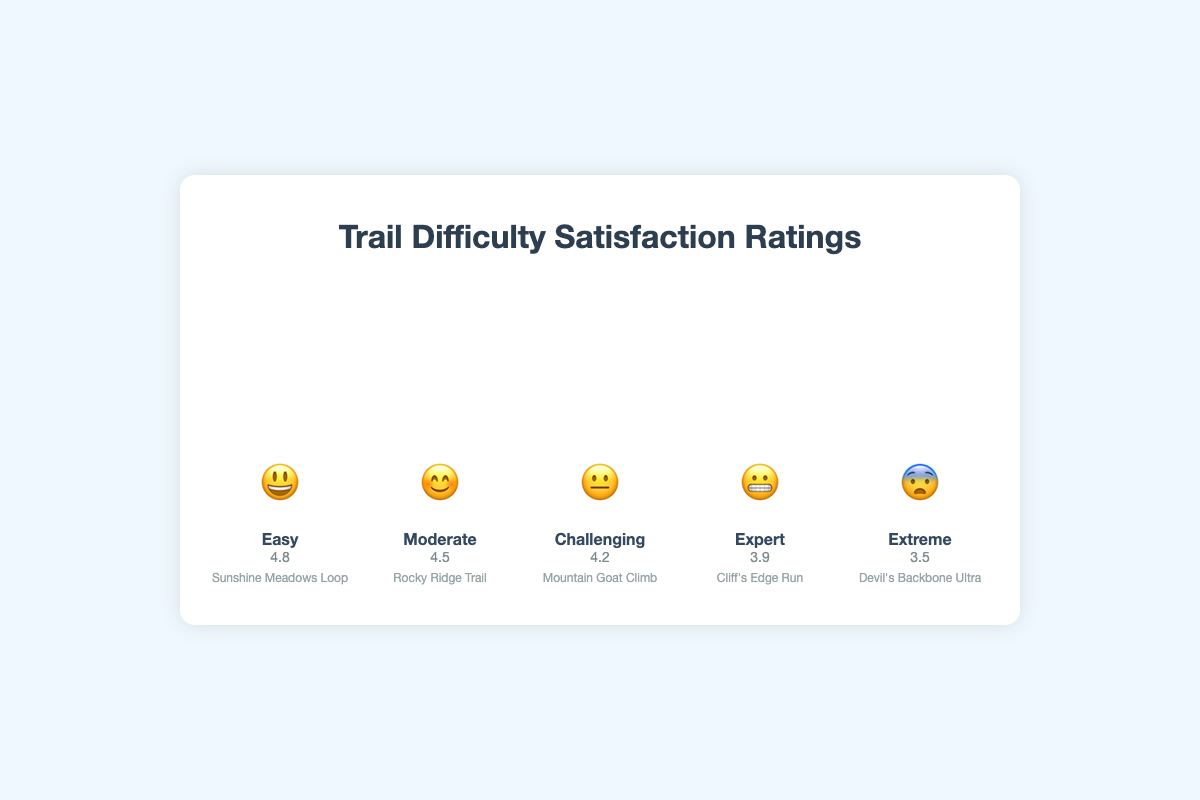what is the trail difficulty level with the highest satisfaction rating? Looking at the figure, the height of the bars represents the satisfaction ratings. The highest bar, corresponding to the satisfaction rating of 4.8, is associated with the "Easy" trail difficulty level.
Answer: Easy which emoji corresponds to the "Challenging" trail difficulty level? In the figure, each trail difficulty level is represented by an emoji. The "Challenging" trail difficulty level is denoted with the 😐 emoji.
Answer: 😐 what is the approximate satisfaction rating for the "Expert" trail difficulty level? The satisfaction rating is shown on the bar for each difficulty level. For the "Expert" level, the satisfaction rating is around 3.9.
Answer: 3.9 what is the satisfaction rating difference between the "Easy" and "Extreme" trail difficulty levels? The satisfaction rating for "Easy" is 4.8 and for "Extreme" is 3.5. Subtracting the rating of "Extreme" from "Easy" gives 4.8 - 3.5 = 1.3.
Answer: 1.3 which trail difficulty levels have satisfaction ratings above 4.0? By inspecting the heights of the bars, the levels with satisfaction ratings above 4.0 are "Easy", "Moderate", and "Challenging", with ratings of 4.8, 4.5, and 4.2 respectively.
Answer: Easy, Moderate, Challenging how does the satisfaction rating for the "Moderate" difficulty level compare to the "Challenging" level? The "Moderate" level has a satisfaction rating of 4.5, whereas the "Challenging" level has a rating of 4.2. Therefore, the "Moderate" level has a slightly higher satisfaction rating compared to the "Challenging" level.
Answer: Moderate is higher which trail difficulty level is depicted with the emoji 😬? The emoji 😬 is associated with the "Expert" trail difficulty level, as shown in the figure.
Answer: Expert how many difficulty levels have satisfaction ratings of 4.2 or less? The figures show satisfaction ratings with bars, where "Challenging" has 4.2, "Expert" has 3.9, and "Extreme" has 3.5. Three difficulty levels have ratings of 4.2 or less.
Answer: Three what is the satisfaction rating trend as the trail difficulty increases? Observing the bars from left to right, representing increasing difficulty from "Easy" to "Extreme", the satisfaction ratings decrease from 4.8 to 3.5. This indicates that as the trail difficulty increases, the satisfaction rating generally decreases.
Answer: Decreasing 